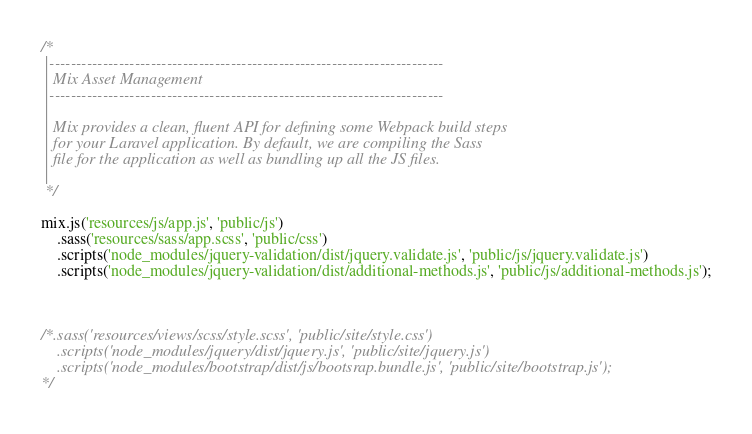Convert code to text. <code><loc_0><loc_0><loc_500><loc_500><_JavaScript_>
/*
 |--------------------------------------------------------------------------
 | Mix Asset Management
 |--------------------------------------------------------------------------
 |
 | Mix provides a clean, fluent API for defining some Webpack build steps
 | for your Laravel application. By default, we are compiling the Sass
 | file for the application as well as bundling up all the JS files.
 |
 */

mix.js('resources/js/app.js', 'public/js')
    .sass('resources/sass/app.scss', 'public/css')
    .scripts('node_modules/jquery-validation/dist/jquery.validate.js', 'public/js/jquery.validate.js')
    .scripts('node_modules/jquery-validation/dist/additional-methods.js', 'public/js/additional-methods.js');



/*.sass('resources/views/scss/style.scss', 'public/site/style.css')
    .scripts('node_modules/jquery/dist/jquery.js', 'public/site/jquery.js')
    .scripts('node_modules/bootstrap/dist/js/bootsrap.bundle.js', 'public/site/bootstrap.js');
*/
</code> 